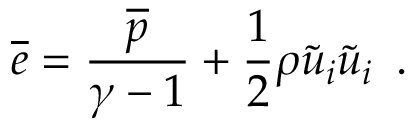<formula> <loc_0><loc_0><loc_500><loc_500>\overline { e } = \frac { \overline { p } } { \gamma - 1 } + \frac { 1 } { 2 } \rho \widetilde { u } _ { i } \widetilde { u } _ { i } \, .</formula> 